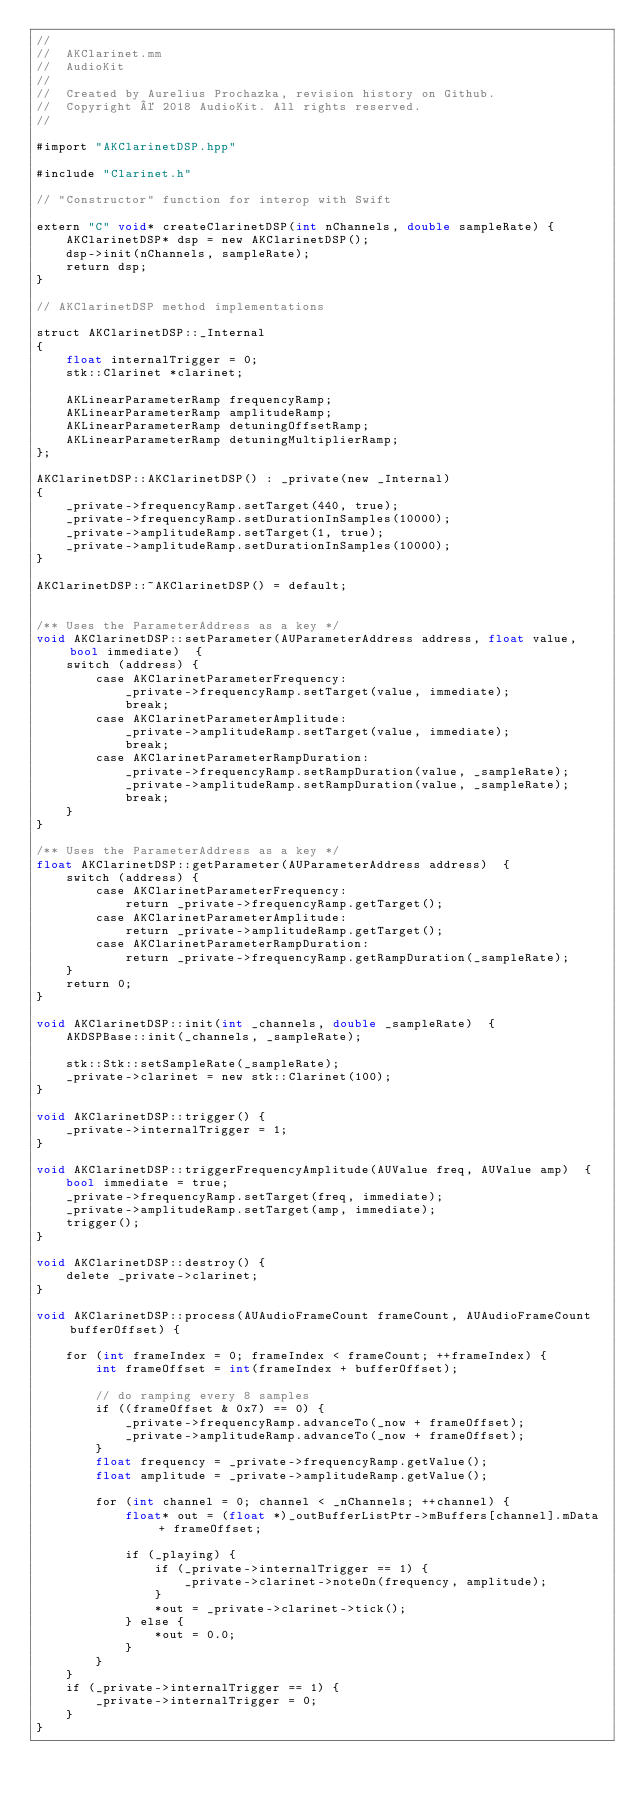<code> <loc_0><loc_0><loc_500><loc_500><_ObjectiveC_>//
//  AKClarinet.mm
//  AudioKit
//
//  Created by Aurelius Prochazka, revision history on Github.
//  Copyright © 2018 AudioKit. All rights reserved.
//

#import "AKClarinetDSP.hpp"

#include "Clarinet.h"

// "Constructor" function for interop with Swift

extern "C" void* createClarinetDSP(int nChannels, double sampleRate) {
    AKClarinetDSP* dsp = new AKClarinetDSP();
    dsp->init(nChannels, sampleRate);
    return dsp;
}

// AKClarinetDSP method implementations

struct AKClarinetDSP::_Internal
{
    float internalTrigger = 0;
    stk::Clarinet *clarinet;
    
    AKLinearParameterRamp frequencyRamp;
    AKLinearParameterRamp amplitudeRamp;
    AKLinearParameterRamp detuningOffsetRamp;
    AKLinearParameterRamp detuningMultiplierRamp;
};

AKClarinetDSP::AKClarinetDSP() : _private(new _Internal)
{
    _private->frequencyRamp.setTarget(440, true);
    _private->frequencyRamp.setDurationInSamples(10000);
    _private->amplitudeRamp.setTarget(1, true);
    _private->amplitudeRamp.setDurationInSamples(10000);
}

AKClarinetDSP::~AKClarinetDSP() = default;


/** Uses the ParameterAddress as a key */
void AKClarinetDSP::setParameter(AUParameterAddress address, float value, bool immediate)  {
    switch (address) {
        case AKClarinetParameterFrequency:
            _private->frequencyRamp.setTarget(value, immediate);
            break;
        case AKClarinetParameterAmplitude:
            _private->amplitudeRamp.setTarget(value, immediate);
            break;
        case AKClarinetParameterRampDuration:
            _private->frequencyRamp.setRampDuration(value, _sampleRate);
            _private->amplitudeRamp.setRampDuration(value, _sampleRate);
            break;
    }
}

/** Uses the ParameterAddress as a key */
float AKClarinetDSP::getParameter(AUParameterAddress address)  {
    switch (address) {
        case AKClarinetParameterFrequency:
            return _private->frequencyRamp.getTarget();
        case AKClarinetParameterAmplitude:
            return _private->amplitudeRamp.getTarget();
        case AKClarinetParameterRampDuration:
            return _private->frequencyRamp.getRampDuration(_sampleRate);
    }
    return 0;
}

void AKClarinetDSP::init(int _channels, double _sampleRate)  {
    AKDSPBase::init(_channels, _sampleRate);
    
    stk::Stk::setSampleRate(_sampleRate);
    _private->clarinet = new stk::Clarinet(100);
}

void AKClarinetDSP::trigger() {
    _private->internalTrigger = 1;
}

void AKClarinetDSP::triggerFrequencyAmplitude(AUValue freq, AUValue amp)  {
    bool immediate = true;
    _private->frequencyRamp.setTarget(freq, immediate);
    _private->amplitudeRamp.setTarget(amp, immediate);
    trigger();
}

void AKClarinetDSP::destroy() {
    delete _private->clarinet;
}

void AKClarinetDSP::process(AUAudioFrameCount frameCount, AUAudioFrameCount bufferOffset) {
    
    for (int frameIndex = 0; frameIndex < frameCount; ++frameIndex) {
        int frameOffset = int(frameIndex + bufferOffset);
        
        // do ramping every 8 samples
        if ((frameOffset & 0x7) == 0) {
            _private->frequencyRamp.advanceTo(_now + frameOffset);
            _private->amplitudeRamp.advanceTo(_now + frameOffset);
        }
        float frequency = _private->frequencyRamp.getValue();
        float amplitude = _private->amplitudeRamp.getValue();
        
        for (int channel = 0; channel < _nChannels; ++channel) {
            float* out = (float *)_outBufferListPtr->mBuffers[channel].mData + frameOffset;
            
            if (_playing) {
                if (_private->internalTrigger == 1) {
                    _private->clarinet->noteOn(frequency, amplitude);
                }
                *out = _private->clarinet->tick();
            } else {
                *out = 0.0;
            }
        }
    }
    if (_private->internalTrigger == 1) {
        _private->internalTrigger = 0;
    }
}
</code> 